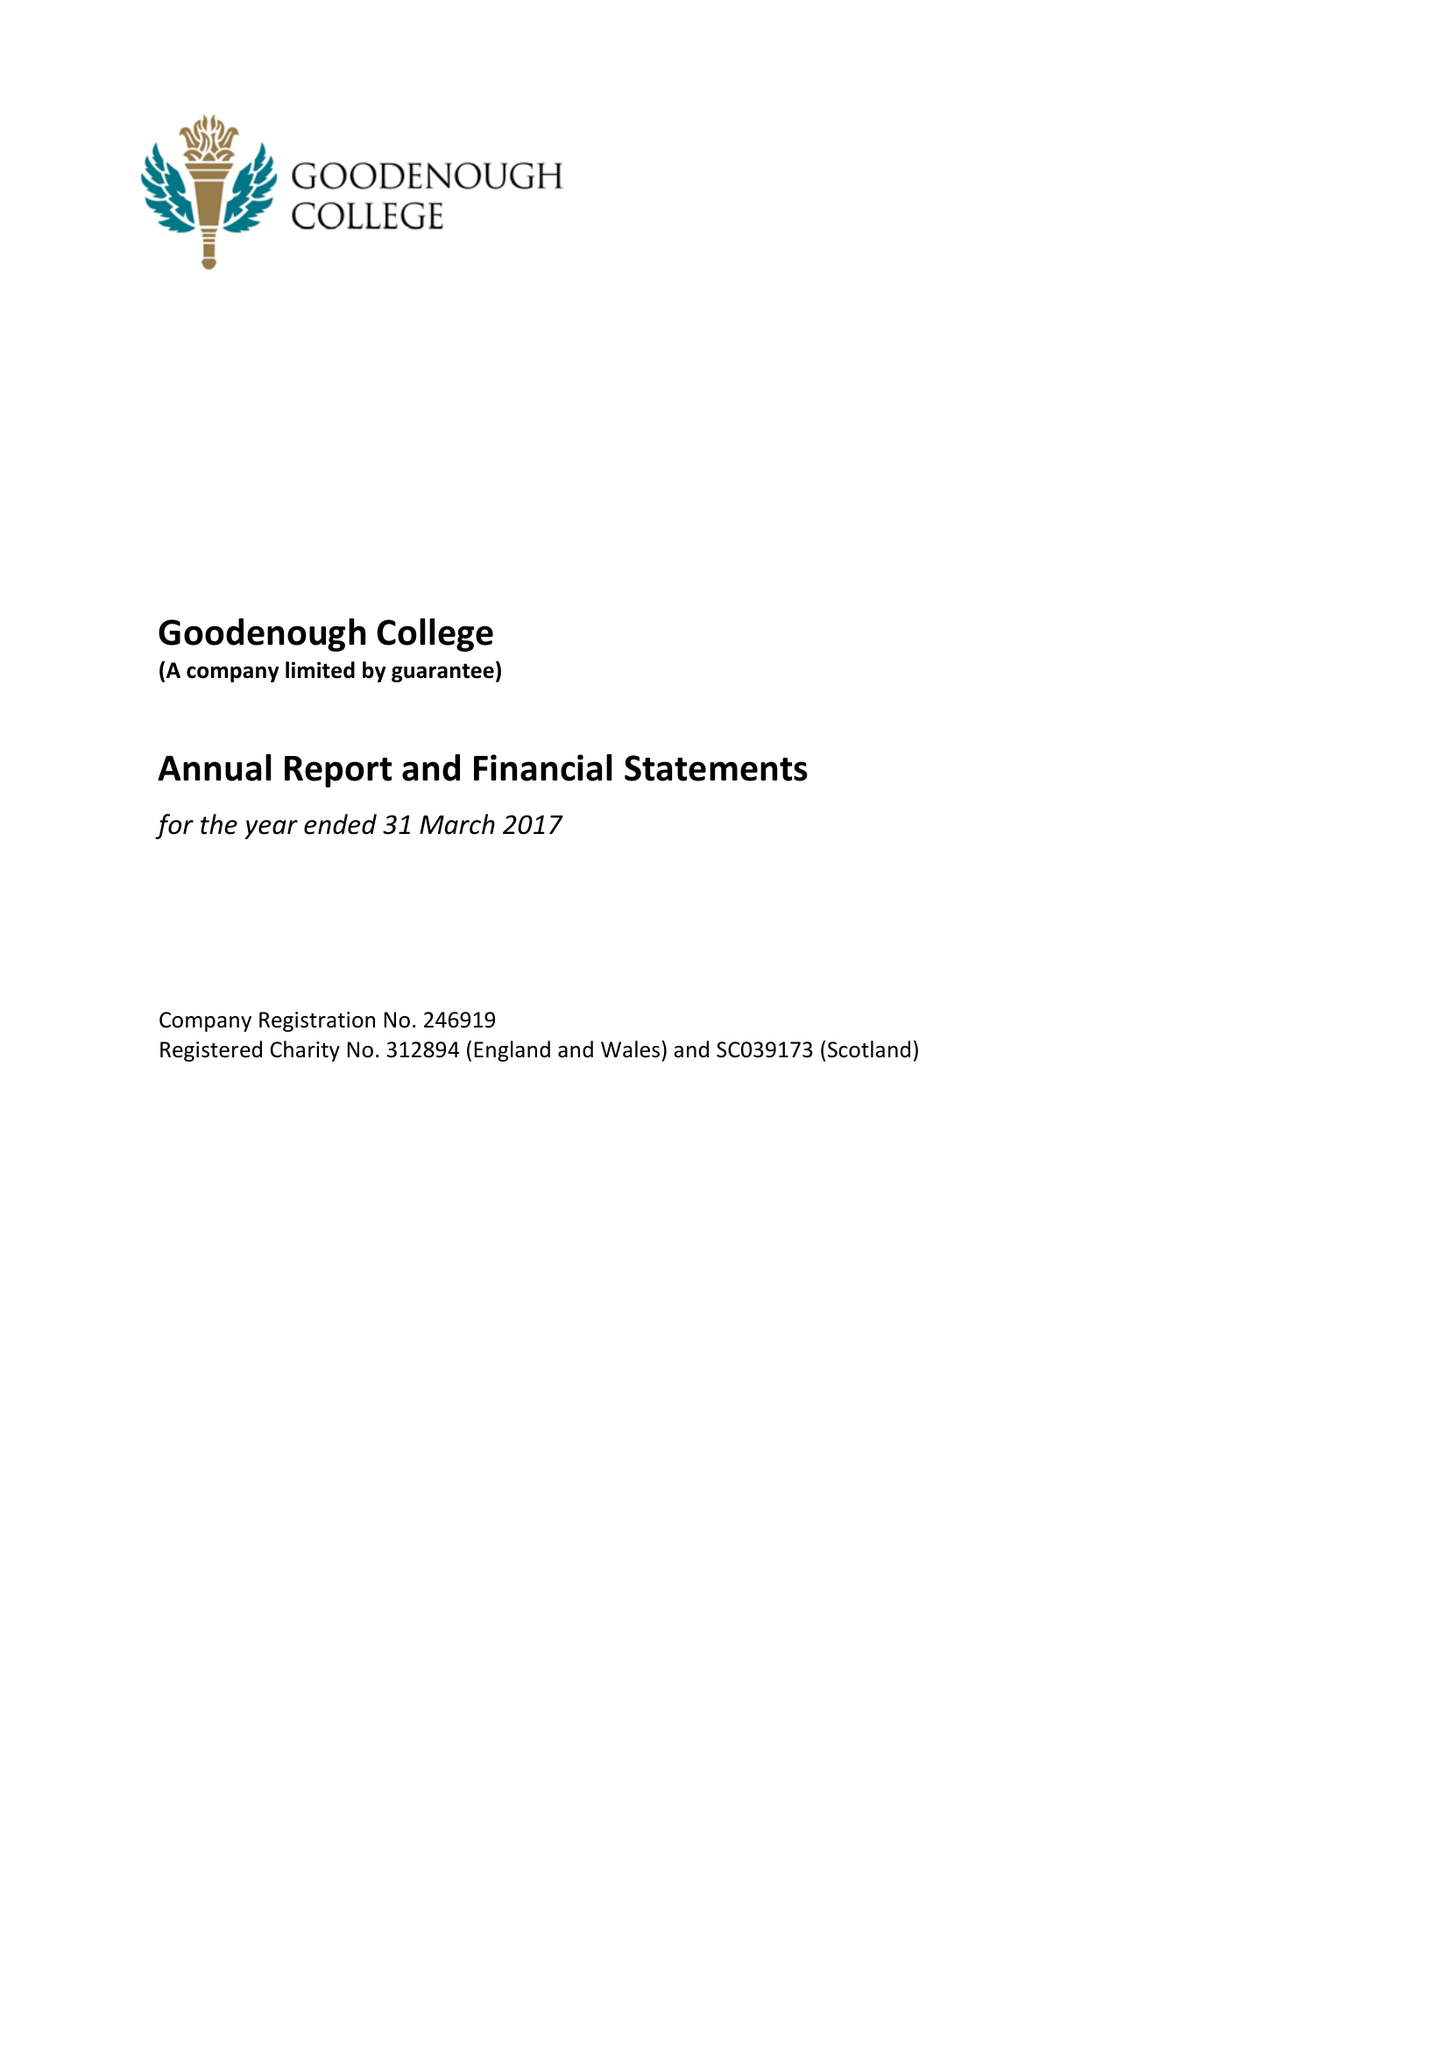What is the value for the spending_annually_in_british_pounds?
Answer the question using a single word or phrase. 11917000.00 